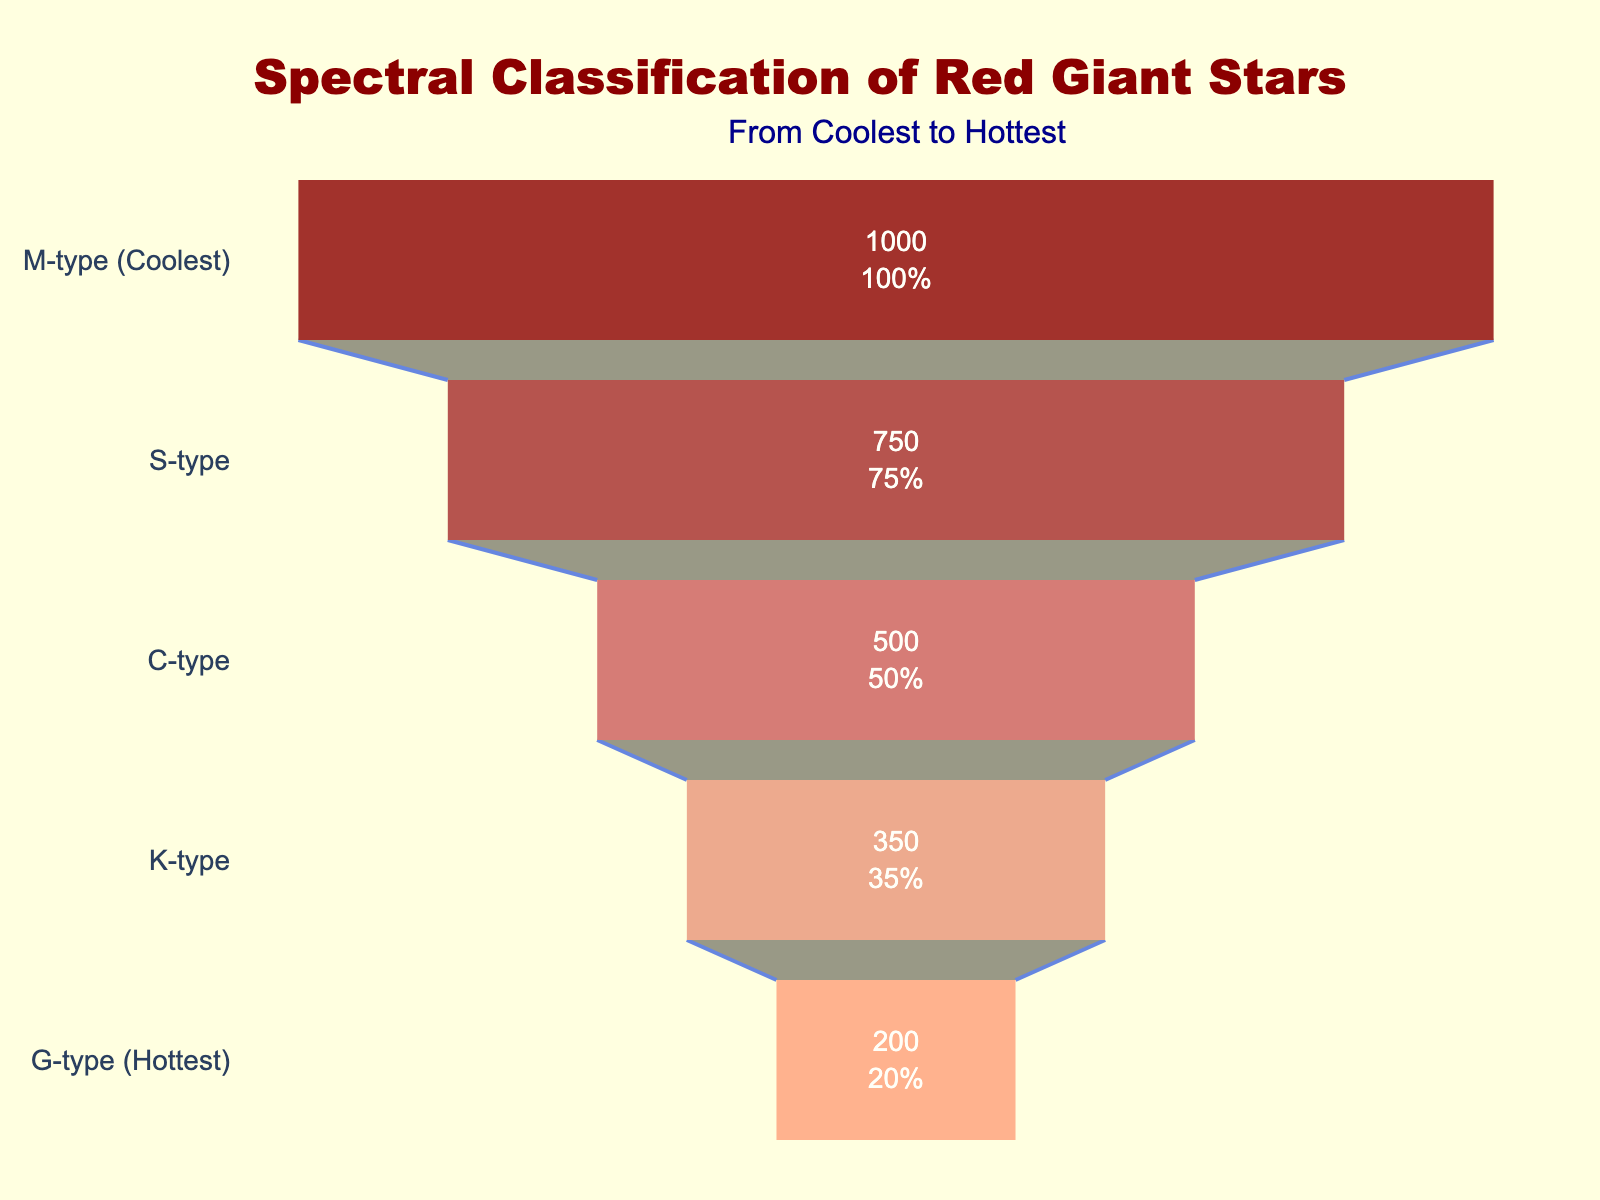What is the title of the funnel chart? The title is located at the top of the chart and reads "Spectral Classification of Red Giant Stars".
Answer: Spectral Classification of Red Giant Stars How many types of red giant stars are mentioned in the chart? The chart shows five stages: M-type, S-type, C-type, K-type, and G-type.
Answer: Five Which type of red giant star is the hottest according to the chart? The hottest type is labeled "G-type (Hottest)" as shown at the smallest section of the funnel chart.
Answer: G-type What is the count of the coolest type of red giant stars? The count is given inside the largest funnel section labeled "M-type (Coolest)" and shows 1000.
Answer: 1000 How much more prevalent are M-type red giants compared to G-type red giants? The count for M-type is 1000, and for G-type, it is 200. Subtract the G-type count from the M-type count: 1000 - 200.
Answer: 800 What percentage of the initial total do S-type stars represent? The S-type section shows text indicating its count and percentage, 750 represents 75% of the initial total, which is 1000.
Answer: 75% Between K-type and C-type stars, which is less common? K-type stars have a count of 350, whereas C-type stars have a count of 500. Therefore, K-type stars are less common.
Answer: K-type What is the combined count of K-type and C-type red giants? Add the counts of K-type (350) and C-type (500): 350 + 500.
Answer: 850 If you summed up the counts of the two hottest types of red giants, what would the total be? Sum the counts for K-type (350) and G-type (200): 350 + 200.
Answer: 550 What is the percentage difference between K-type and M-type stars? M-type has 1000 stars and K-type has 350 stars. Calculate the difference (1000 - 350), then divide by M-type count (1000) and multiply by 100 to get the percentage: ((1000 - 350) / 1000) * 100.
Answer: 65% 